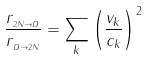<formula> <loc_0><loc_0><loc_500><loc_500>\frac { r _ { _ { 2 N \rightarrow D } } } { r _ { _ { D \rightarrow 2 N } } } = \sum _ { k } \left ( \frac { v _ { k } } { c _ { k } } \right ) ^ { 2 } \ \</formula> 